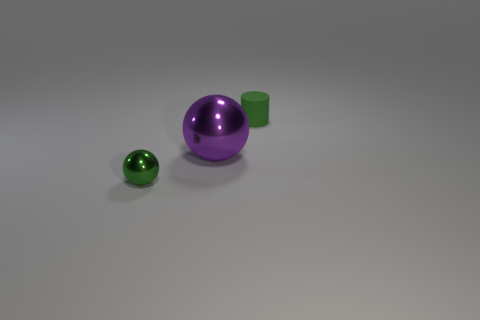What could be the possible materials these objects are made of? The two spheres exhibit a high-gloss finish, typically associated with materials like glass, polished metal, or plastic. The cylinder, with its matte finish, may be crafted from a rubbery substance, or possibly a matte-finished plastic or ceramic. 